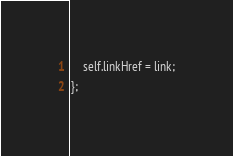<code> <loc_0><loc_0><loc_500><loc_500><_JavaScript_>	self.linkHref = link;
};</code> 